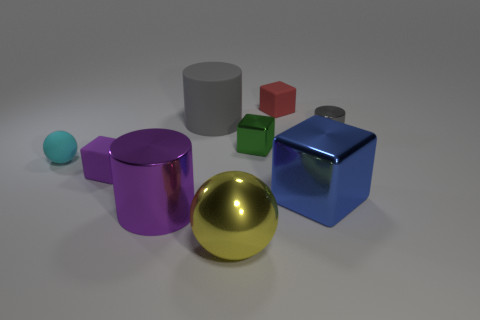Add 1 small cyan balls. How many objects exist? 10 Subtract all balls. How many objects are left? 7 Add 7 big cyan balls. How many big cyan balls exist? 7 Subtract 0 gray cubes. How many objects are left? 9 Subtract all small metal objects. Subtract all red cubes. How many objects are left? 6 Add 5 green cubes. How many green cubes are left? 6 